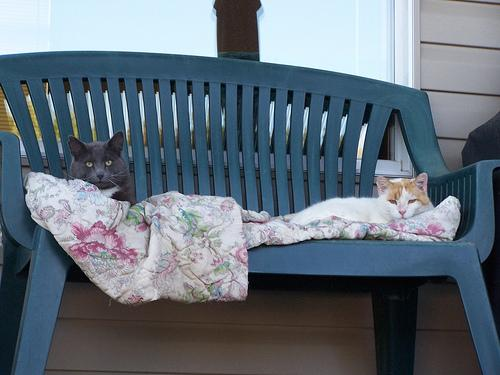What kind of prey do these animals hunt? Please explain your reasoning. small. These are little domestic animals 